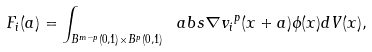<formula> <loc_0><loc_0><loc_500><loc_500>F _ { i } ( a ) = \int _ { B ^ { m - p } ( 0 , 1 ) \times B ^ { p } ( 0 , 1 ) } \ a b s { \nabla v _ { i } } ^ { p } ( x + a ) \phi ( x ) d V ( x ) ,</formula> 